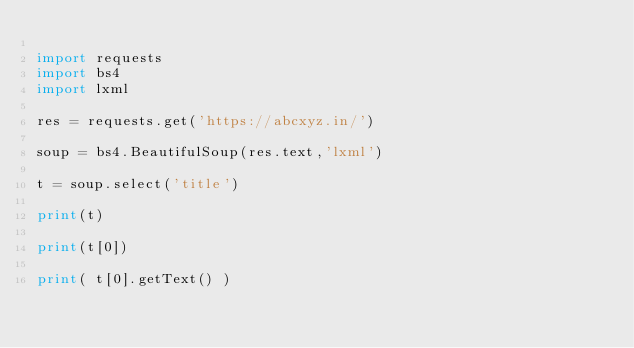<code> <loc_0><loc_0><loc_500><loc_500><_Python_>
import requests
import bs4
import lxml

res = requests.get('https://abcxyz.in/')

soup = bs4.BeautifulSoup(res.text,'lxml')

t = soup.select('title')

print(t)

print(t[0])

print( t[0].getText() )</code> 